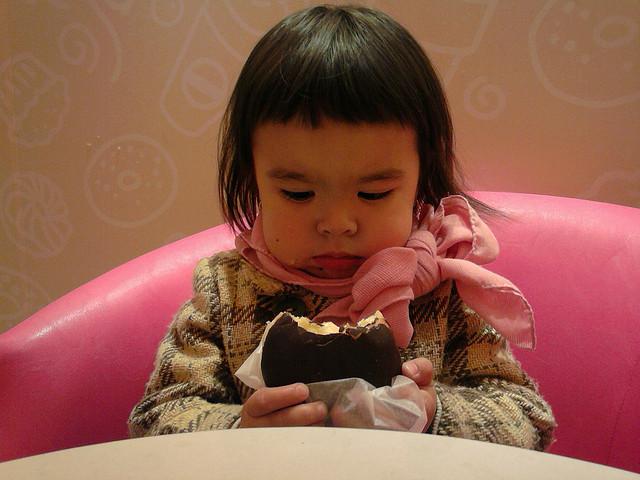How many girls are present?
Keep it brief. 1. Is this girl looking at food?
Answer briefly. Yes. What color is her scarf?
Quick response, please. Pink. 